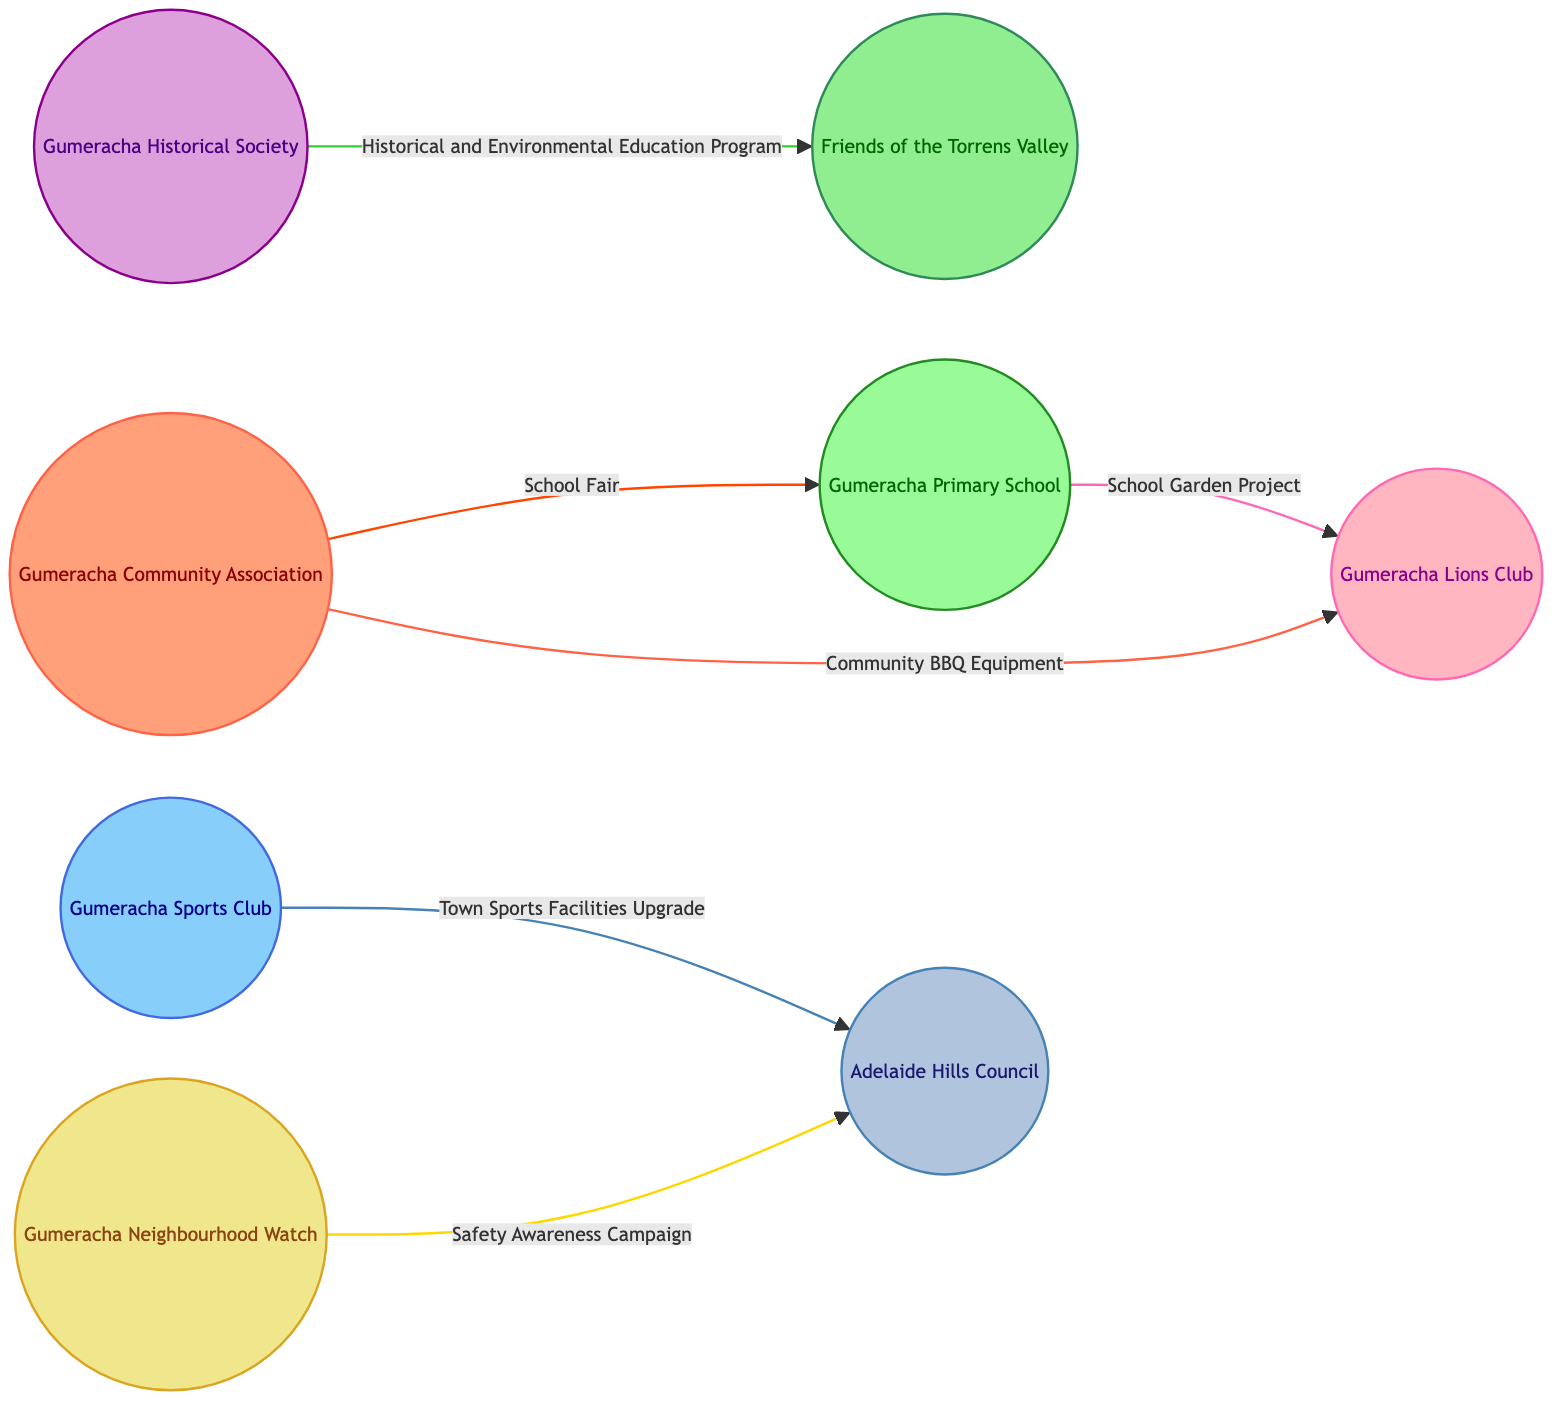What is the total number of community organizations represented in the diagram? The diagram lists 8 nodes, each representing a different community organization. By counting these, we find that the total number is 8.
Answer: 8 Which organization is connected to Gumeracha Neighbourhood Watch? Looking at the edges where Gumeracha Neighbourhood Watch is involved, I see it connects with Adelaide Hills Council with a "Safety Awareness Campaign" joint event.
Answer: Adelaide Hills Council What type of relationship exists between Gumeracha Sports Club and Adelaide Hills Council? By examining the edge connecting these two nodes, I find that it shows a "Collaborative Project" relationship.
Answer: Collaborative Project How many joint events are noted in the diagram? There are 3 edges labeled as "Joint Event"; one with Gumeracha Community Association and Gumeracha Primary School, one with Gumeracha Neighbourhood Watch and Adelaide Hills Council, and one with Gumeracha Sports Club and Gumeracha Lions Club, totaling to 2 joint events.
Answer: 2 Which two organizations are involved in a Historical and Environmental Education Program? Looking at the edge labeled with "Historical and Environmental Education Program," I identify that it connects Gumeracha Historical Society and Friends of the Torrens Valley.
Answer: Gumeracha Historical Society and Friends of the Torrens Valley How is Gumeracha Primary School connected to Gumeracha Lions Club? The diagram shows a collaborative project between these two organizations through the "School Garden Project" edge.
Answer: School Garden Project Which organization collaborates in the Town Sports Facilities Upgrade project? The edge connecting Gumeracha Sports Club and Adelaide Hills Council denotes their collaboration in the Town Sports Facilities Upgrade.
Answer: Adelaide Hills Council Name an organization that shares resources with Gumeracha Community Association. The relationship "Shared Resources" is indicated between Gumeracha Community Association and Gumeracha Lions Club, where they share community BBQ equipment.
Answer: Gumeracha Lions Club 